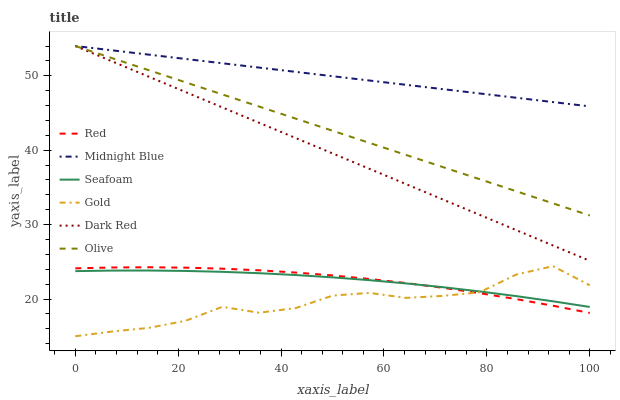Does Gold have the minimum area under the curve?
Answer yes or no. Yes. Does Midnight Blue have the maximum area under the curve?
Answer yes or no. Yes. Does Dark Red have the minimum area under the curve?
Answer yes or no. No. Does Dark Red have the maximum area under the curve?
Answer yes or no. No. Is Dark Red the smoothest?
Answer yes or no. Yes. Is Gold the roughest?
Answer yes or no. Yes. Is Gold the smoothest?
Answer yes or no. No. Is Dark Red the roughest?
Answer yes or no. No. Does Gold have the lowest value?
Answer yes or no. Yes. Does Dark Red have the lowest value?
Answer yes or no. No. Does Olive have the highest value?
Answer yes or no. Yes. Does Gold have the highest value?
Answer yes or no. No. Is Seafoam less than Olive?
Answer yes or no. Yes. Is Dark Red greater than Red?
Answer yes or no. Yes. Does Red intersect Gold?
Answer yes or no. Yes. Is Red less than Gold?
Answer yes or no. No. Is Red greater than Gold?
Answer yes or no. No. Does Seafoam intersect Olive?
Answer yes or no. No. 